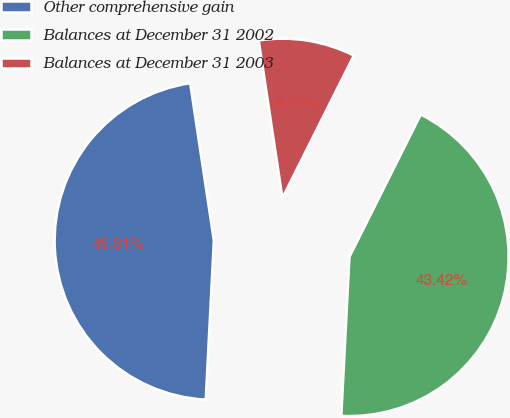Convert chart. <chart><loc_0><loc_0><loc_500><loc_500><pie_chart><fcel>Other comprehensive gain<fcel>Balances at December 31 2002<fcel>Balances at December 31 2003<nl><fcel>46.81%<fcel>43.42%<fcel>9.77%<nl></chart> 